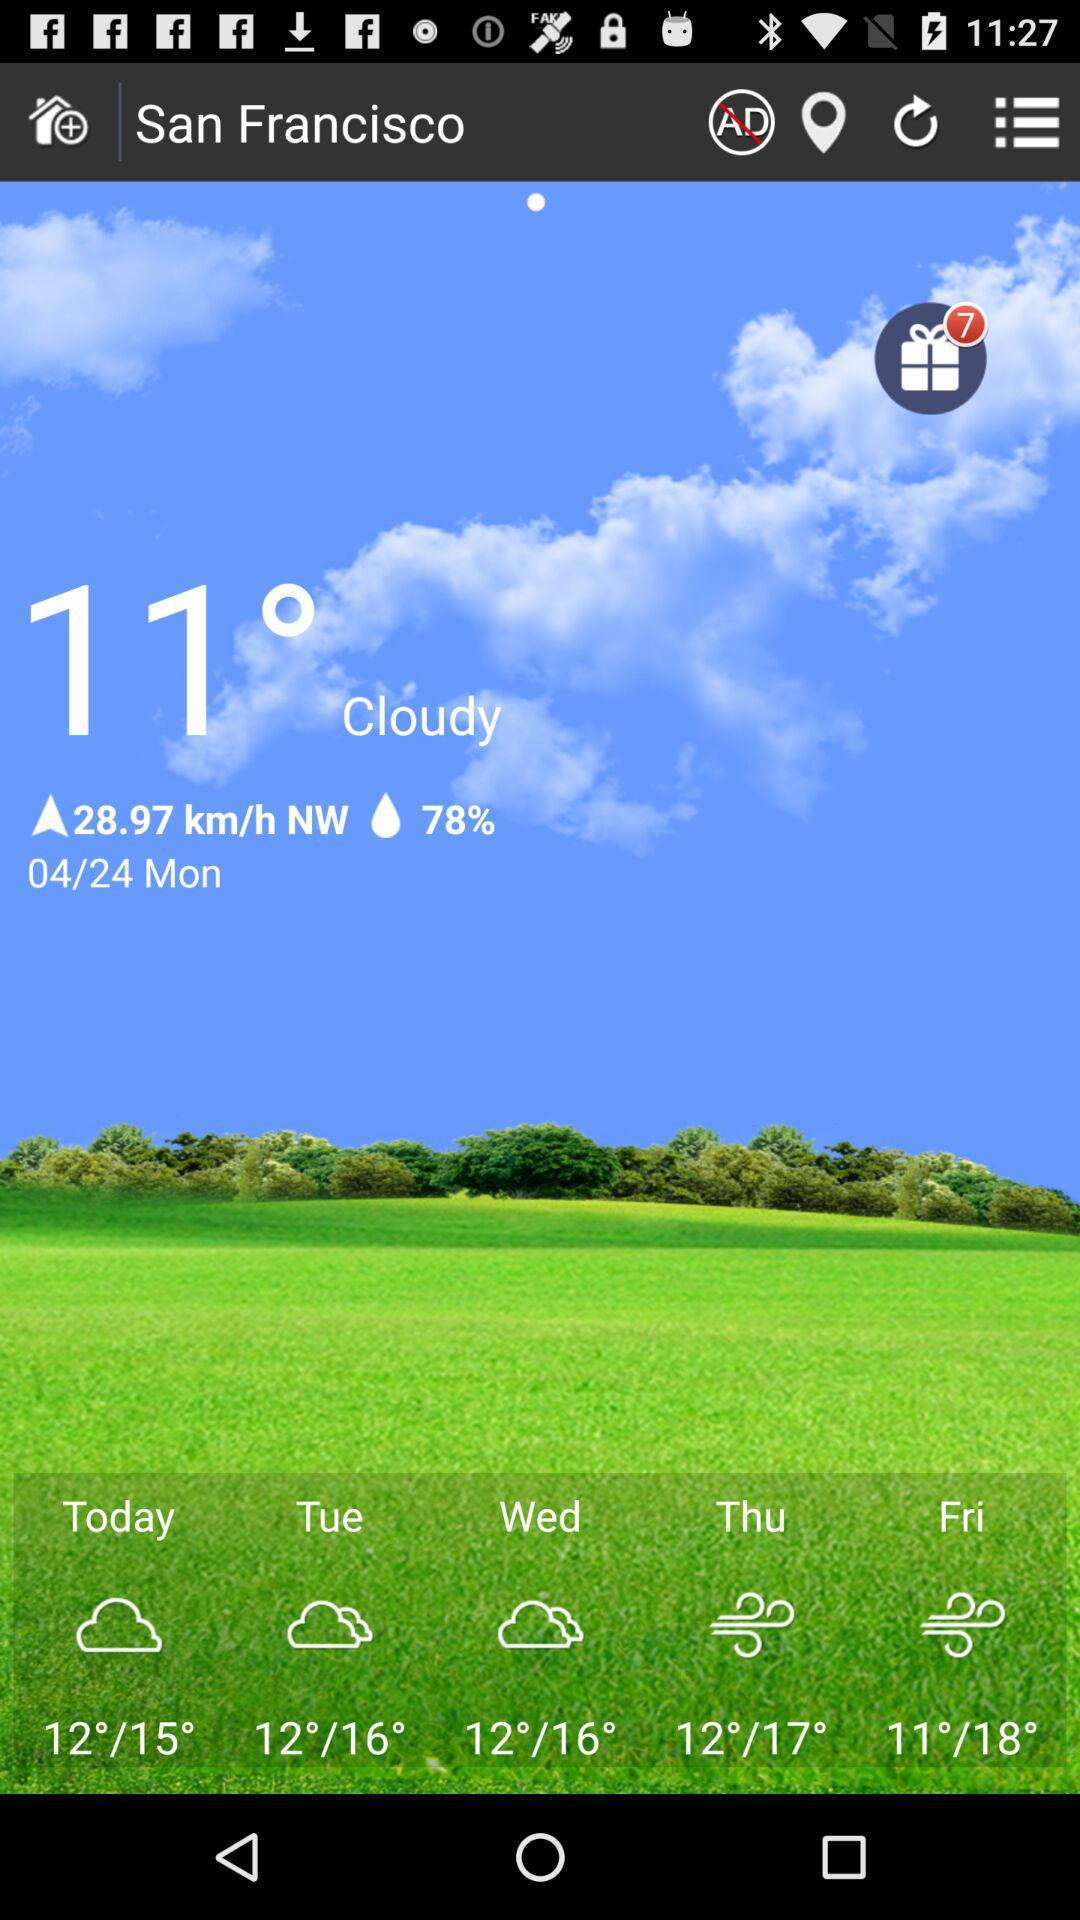What is the location? The location is San Francisco. 